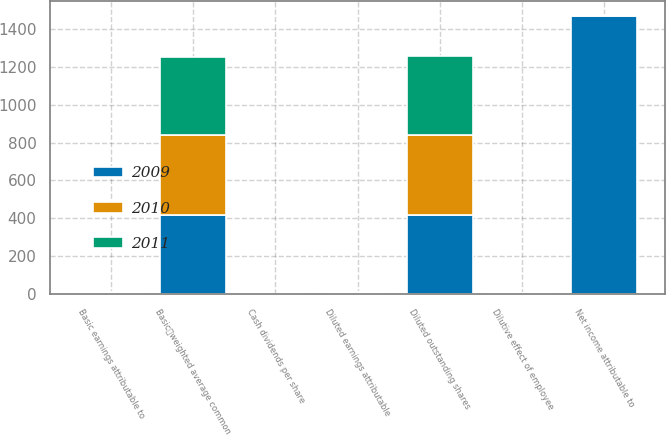Convert chart to OTSL. <chart><loc_0><loc_0><loc_500><loc_500><stacked_bar_chart><ecel><fcel>Net income attributable to<fcel>Basicweighted average common<fcel>Dilutive effect of employee<fcel>Diluted outstanding shares<fcel>Basic earnings attributable to<fcel>Diluted earnings attributable<fcel>Cash dividends per share<nl><fcel>2010<fcel>3.99<fcel>422<fcel>2<fcel>424<fcel>4.73<fcel>4.7<fcel>0.45<nl><fcel>2011<fcel>3.99<fcel>417<fcel>2<fcel>419<fcel>3.99<fcel>3.98<fcel>0.41<nl><fcel>2009<fcel>1469<fcel>416<fcel>1<fcel>417<fcel>3.53<fcel>3.52<fcel>1.1<nl></chart> 